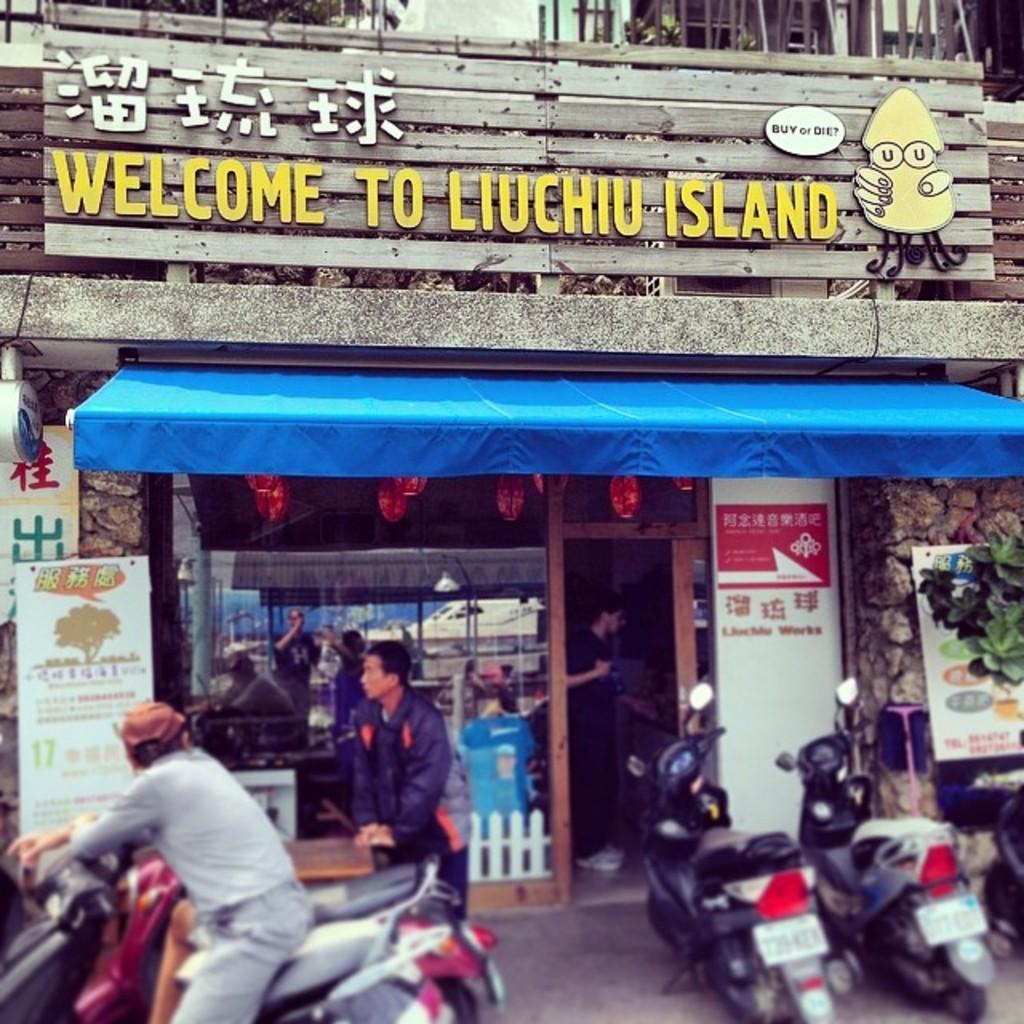What type of establishment is shown in the image? There is a shop in the image. What can be seen in front of the shop? There are vehicles parked in front of the shop. Are there any people visible in the image? Yes, there are people walking in the image. What else can be seen in the image besides the shop and people? There are banners visible in the image. What type of structure is the shop built on in the image? The provided facts do not mention any specific structure or foundation for the shop in the image. 